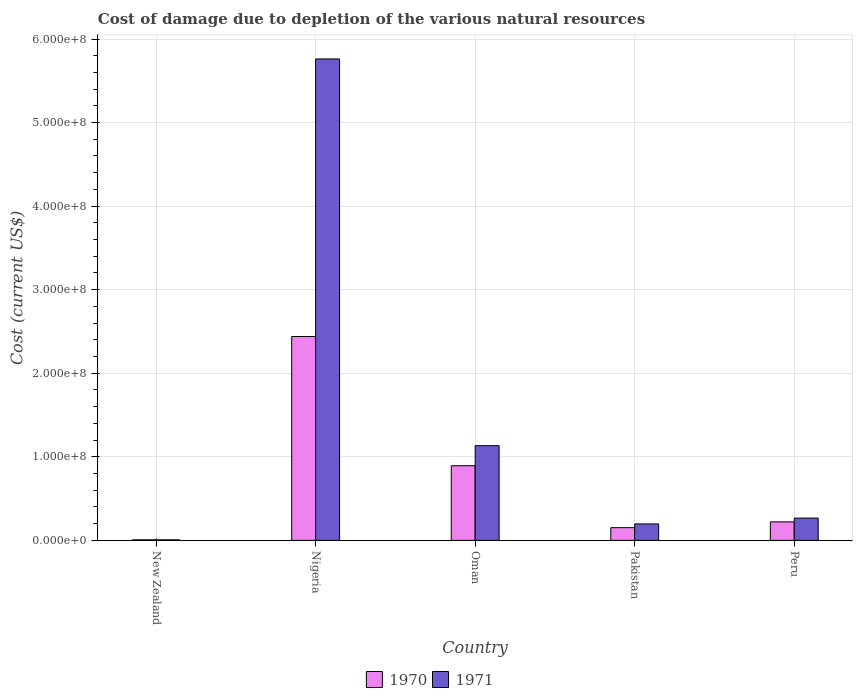How many different coloured bars are there?
Offer a terse response. 2. How many groups of bars are there?
Your answer should be very brief. 5. Are the number of bars per tick equal to the number of legend labels?
Ensure brevity in your answer.  Yes. Are the number of bars on each tick of the X-axis equal?
Offer a terse response. Yes. How many bars are there on the 2nd tick from the left?
Provide a short and direct response. 2. What is the label of the 5th group of bars from the left?
Provide a succinct answer. Peru. What is the cost of damage caused due to the depletion of various natural resources in 1971 in New Zealand?
Your answer should be compact. 6.53e+05. Across all countries, what is the maximum cost of damage caused due to the depletion of various natural resources in 1970?
Your response must be concise. 2.44e+08. Across all countries, what is the minimum cost of damage caused due to the depletion of various natural resources in 1971?
Keep it short and to the point. 6.53e+05. In which country was the cost of damage caused due to the depletion of various natural resources in 1971 maximum?
Your answer should be very brief. Nigeria. In which country was the cost of damage caused due to the depletion of various natural resources in 1970 minimum?
Offer a terse response. New Zealand. What is the total cost of damage caused due to the depletion of various natural resources in 1971 in the graph?
Offer a terse response. 7.37e+08. What is the difference between the cost of damage caused due to the depletion of various natural resources in 1970 in New Zealand and that in Oman?
Your answer should be compact. -8.87e+07. What is the difference between the cost of damage caused due to the depletion of various natural resources in 1971 in Pakistan and the cost of damage caused due to the depletion of various natural resources in 1970 in Nigeria?
Your response must be concise. -2.24e+08. What is the average cost of damage caused due to the depletion of various natural resources in 1971 per country?
Your response must be concise. 1.47e+08. What is the difference between the cost of damage caused due to the depletion of various natural resources of/in 1970 and cost of damage caused due to the depletion of various natural resources of/in 1971 in Pakistan?
Your answer should be compact. -4.48e+06. In how many countries, is the cost of damage caused due to the depletion of various natural resources in 1970 greater than 360000000 US$?
Provide a succinct answer. 0. What is the ratio of the cost of damage caused due to the depletion of various natural resources in 1970 in New Zealand to that in Peru?
Your answer should be compact. 0.03. Is the cost of damage caused due to the depletion of various natural resources in 1970 in Nigeria less than that in Pakistan?
Keep it short and to the point. No. Is the difference between the cost of damage caused due to the depletion of various natural resources in 1970 in Pakistan and Peru greater than the difference between the cost of damage caused due to the depletion of various natural resources in 1971 in Pakistan and Peru?
Keep it short and to the point. Yes. What is the difference between the highest and the second highest cost of damage caused due to the depletion of various natural resources in 1970?
Your answer should be very brief. -2.22e+08. What is the difference between the highest and the lowest cost of damage caused due to the depletion of various natural resources in 1971?
Keep it short and to the point. 5.75e+08. Is the sum of the cost of damage caused due to the depletion of various natural resources in 1971 in New Zealand and Pakistan greater than the maximum cost of damage caused due to the depletion of various natural resources in 1970 across all countries?
Offer a terse response. No. How many bars are there?
Ensure brevity in your answer.  10. Are all the bars in the graph horizontal?
Your answer should be very brief. No. How many countries are there in the graph?
Offer a very short reply. 5. Are the values on the major ticks of Y-axis written in scientific E-notation?
Make the answer very short. Yes. Does the graph contain any zero values?
Your response must be concise. No. Does the graph contain grids?
Ensure brevity in your answer.  Yes. How many legend labels are there?
Ensure brevity in your answer.  2. How are the legend labels stacked?
Ensure brevity in your answer.  Horizontal. What is the title of the graph?
Give a very brief answer. Cost of damage due to depletion of the various natural resources. What is the label or title of the X-axis?
Provide a succinct answer. Country. What is the label or title of the Y-axis?
Ensure brevity in your answer.  Cost (current US$). What is the Cost (current US$) in 1970 in New Zealand?
Keep it short and to the point. 6.80e+05. What is the Cost (current US$) in 1971 in New Zealand?
Provide a short and direct response. 6.53e+05. What is the Cost (current US$) in 1970 in Nigeria?
Provide a succinct answer. 2.44e+08. What is the Cost (current US$) of 1971 in Nigeria?
Provide a short and direct response. 5.76e+08. What is the Cost (current US$) of 1970 in Oman?
Provide a short and direct response. 8.94e+07. What is the Cost (current US$) of 1971 in Oman?
Provide a short and direct response. 1.13e+08. What is the Cost (current US$) of 1970 in Pakistan?
Provide a succinct answer. 1.52e+07. What is the Cost (current US$) in 1971 in Pakistan?
Offer a very short reply. 1.97e+07. What is the Cost (current US$) of 1970 in Peru?
Keep it short and to the point. 2.22e+07. What is the Cost (current US$) of 1971 in Peru?
Keep it short and to the point. 2.67e+07. Across all countries, what is the maximum Cost (current US$) of 1970?
Offer a very short reply. 2.44e+08. Across all countries, what is the maximum Cost (current US$) of 1971?
Provide a short and direct response. 5.76e+08. Across all countries, what is the minimum Cost (current US$) of 1970?
Keep it short and to the point. 6.80e+05. Across all countries, what is the minimum Cost (current US$) in 1971?
Your answer should be very brief. 6.53e+05. What is the total Cost (current US$) of 1970 in the graph?
Ensure brevity in your answer.  3.71e+08. What is the total Cost (current US$) of 1971 in the graph?
Keep it short and to the point. 7.37e+08. What is the difference between the Cost (current US$) of 1970 in New Zealand and that in Nigeria?
Your response must be concise. -2.43e+08. What is the difference between the Cost (current US$) of 1971 in New Zealand and that in Nigeria?
Give a very brief answer. -5.75e+08. What is the difference between the Cost (current US$) of 1970 in New Zealand and that in Oman?
Offer a terse response. -8.87e+07. What is the difference between the Cost (current US$) in 1971 in New Zealand and that in Oman?
Give a very brief answer. -1.13e+08. What is the difference between the Cost (current US$) of 1970 in New Zealand and that in Pakistan?
Give a very brief answer. -1.46e+07. What is the difference between the Cost (current US$) in 1971 in New Zealand and that in Pakistan?
Give a very brief answer. -1.91e+07. What is the difference between the Cost (current US$) of 1970 in New Zealand and that in Peru?
Ensure brevity in your answer.  -2.15e+07. What is the difference between the Cost (current US$) in 1971 in New Zealand and that in Peru?
Your response must be concise. -2.60e+07. What is the difference between the Cost (current US$) of 1970 in Nigeria and that in Oman?
Provide a succinct answer. 1.55e+08. What is the difference between the Cost (current US$) of 1971 in Nigeria and that in Oman?
Offer a very short reply. 4.63e+08. What is the difference between the Cost (current US$) in 1970 in Nigeria and that in Pakistan?
Keep it short and to the point. 2.29e+08. What is the difference between the Cost (current US$) in 1971 in Nigeria and that in Pakistan?
Ensure brevity in your answer.  5.56e+08. What is the difference between the Cost (current US$) of 1970 in Nigeria and that in Peru?
Your answer should be compact. 2.22e+08. What is the difference between the Cost (current US$) of 1971 in Nigeria and that in Peru?
Offer a terse response. 5.49e+08. What is the difference between the Cost (current US$) in 1970 in Oman and that in Pakistan?
Give a very brief answer. 7.41e+07. What is the difference between the Cost (current US$) in 1971 in Oman and that in Pakistan?
Offer a terse response. 9.36e+07. What is the difference between the Cost (current US$) in 1970 in Oman and that in Peru?
Your answer should be compact. 6.72e+07. What is the difference between the Cost (current US$) in 1971 in Oman and that in Peru?
Your answer should be compact. 8.66e+07. What is the difference between the Cost (current US$) in 1970 in Pakistan and that in Peru?
Your response must be concise. -6.92e+06. What is the difference between the Cost (current US$) in 1971 in Pakistan and that in Peru?
Your response must be concise. -6.98e+06. What is the difference between the Cost (current US$) of 1970 in New Zealand and the Cost (current US$) of 1971 in Nigeria?
Offer a very short reply. -5.75e+08. What is the difference between the Cost (current US$) of 1970 in New Zealand and the Cost (current US$) of 1971 in Oman?
Offer a very short reply. -1.13e+08. What is the difference between the Cost (current US$) of 1970 in New Zealand and the Cost (current US$) of 1971 in Pakistan?
Offer a very short reply. -1.90e+07. What is the difference between the Cost (current US$) in 1970 in New Zealand and the Cost (current US$) in 1971 in Peru?
Your response must be concise. -2.60e+07. What is the difference between the Cost (current US$) of 1970 in Nigeria and the Cost (current US$) of 1971 in Oman?
Provide a succinct answer. 1.31e+08. What is the difference between the Cost (current US$) of 1970 in Nigeria and the Cost (current US$) of 1971 in Pakistan?
Provide a short and direct response. 2.24e+08. What is the difference between the Cost (current US$) of 1970 in Nigeria and the Cost (current US$) of 1971 in Peru?
Offer a terse response. 2.17e+08. What is the difference between the Cost (current US$) in 1970 in Oman and the Cost (current US$) in 1971 in Pakistan?
Make the answer very short. 6.96e+07. What is the difference between the Cost (current US$) of 1970 in Oman and the Cost (current US$) of 1971 in Peru?
Provide a short and direct response. 6.27e+07. What is the difference between the Cost (current US$) in 1970 in Pakistan and the Cost (current US$) in 1971 in Peru?
Keep it short and to the point. -1.15e+07. What is the average Cost (current US$) in 1970 per country?
Your answer should be very brief. 7.43e+07. What is the average Cost (current US$) in 1971 per country?
Provide a short and direct response. 1.47e+08. What is the difference between the Cost (current US$) of 1970 and Cost (current US$) of 1971 in New Zealand?
Offer a terse response. 2.77e+04. What is the difference between the Cost (current US$) in 1970 and Cost (current US$) in 1971 in Nigeria?
Provide a short and direct response. -3.32e+08. What is the difference between the Cost (current US$) in 1970 and Cost (current US$) in 1971 in Oman?
Offer a very short reply. -2.40e+07. What is the difference between the Cost (current US$) of 1970 and Cost (current US$) of 1971 in Pakistan?
Your response must be concise. -4.48e+06. What is the difference between the Cost (current US$) in 1970 and Cost (current US$) in 1971 in Peru?
Provide a short and direct response. -4.53e+06. What is the ratio of the Cost (current US$) of 1970 in New Zealand to that in Nigeria?
Provide a short and direct response. 0. What is the ratio of the Cost (current US$) of 1971 in New Zealand to that in Nigeria?
Offer a terse response. 0. What is the ratio of the Cost (current US$) of 1970 in New Zealand to that in Oman?
Provide a short and direct response. 0.01. What is the ratio of the Cost (current US$) of 1971 in New Zealand to that in Oman?
Keep it short and to the point. 0.01. What is the ratio of the Cost (current US$) of 1970 in New Zealand to that in Pakistan?
Provide a short and direct response. 0.04. What is the ratio of the Cost (current US$) in 1971 in New Zealand to that in Pakistan?
Offer a very short reply. 0.03. What is the ratio of the Cost (current US$) of 1970 in New Zealand to that in Peru?
Your answer should be compact. 0.03. What is the ratio of the Cost (current US$) in 1971 in New Zealand to that in Peru?
Keep it short and to the point. 0.02. What is the ratio of the Cost (current US$) in 1970 in Nigeria to that in Oman?
Provide a succinct answer. 2.73. What is the ratio of the Cost (current US$) in 1971 in Nigeria to that in Oman?
Provide a short and direct response. 5.08. What is the ratio of the Cost (current US$) of 1970 in Nigeria to that in Pakistan?
Offer a very short reply. 16.02. What is the ratio of the Cost (current US$) in 1971 in Nigeria to that in Pakistan?
Ensure brevity in your answer.  29.23. What is the ratio of the Cost (current US$) in 1970 in Nigeria to that in Peru?
Offer a very short reply. 11.01. What is the ratio of the Cost (current US$) of 1971 in Nigeria to that in Peru?
Make the answer very short. 21.59. What is the ratio of the Cost (current US$) in 1970 in Oman to that in Pakistan?
Offer a very short reply. 5.87. What is the ratio of the Cost (current US$) of 1971 in Oman to that in Pakistan?
Give a very brief answer. 5.75. What is the ratio of the Cost (current US$) in 1970 in Oman to that in Peru?
Ensure brevity in your answer.  4.03. What is the ratio of the Cost (current US$) in 1971 in Oman to that in Peru?
Provide a succinct answer. 4.25. What is the ratio of the Cost (current US$) in 1970 in Pakistan to that in Peru?
Give a very brief answer. 0.69. What is the ratio of the Cost (current US$) of 1971 in Pakistan to that in Peru?
Provide a short and direct response. 0.74. What is the difference between the highest and the second highest Cost (current US$) of 1970?
Ensure brevity in your answer.  1.55e+08. What is the difference between the highest and the second highest Cost (current US$) of 1971?
Make the answer very short. 4.63e+08. What is the difference between the highest and the lowest Cost (current US$) of 1970?
Provide a succinct answer. 2.43e+08. What is the difference between the highest and the lowest Cost (current US$) of 1971?
Your answer should be very brief. 5.75e+08. 